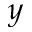Convert formula to latex. <formula><loc_0><loc_0><loc_500><loc_500>y</formula> 